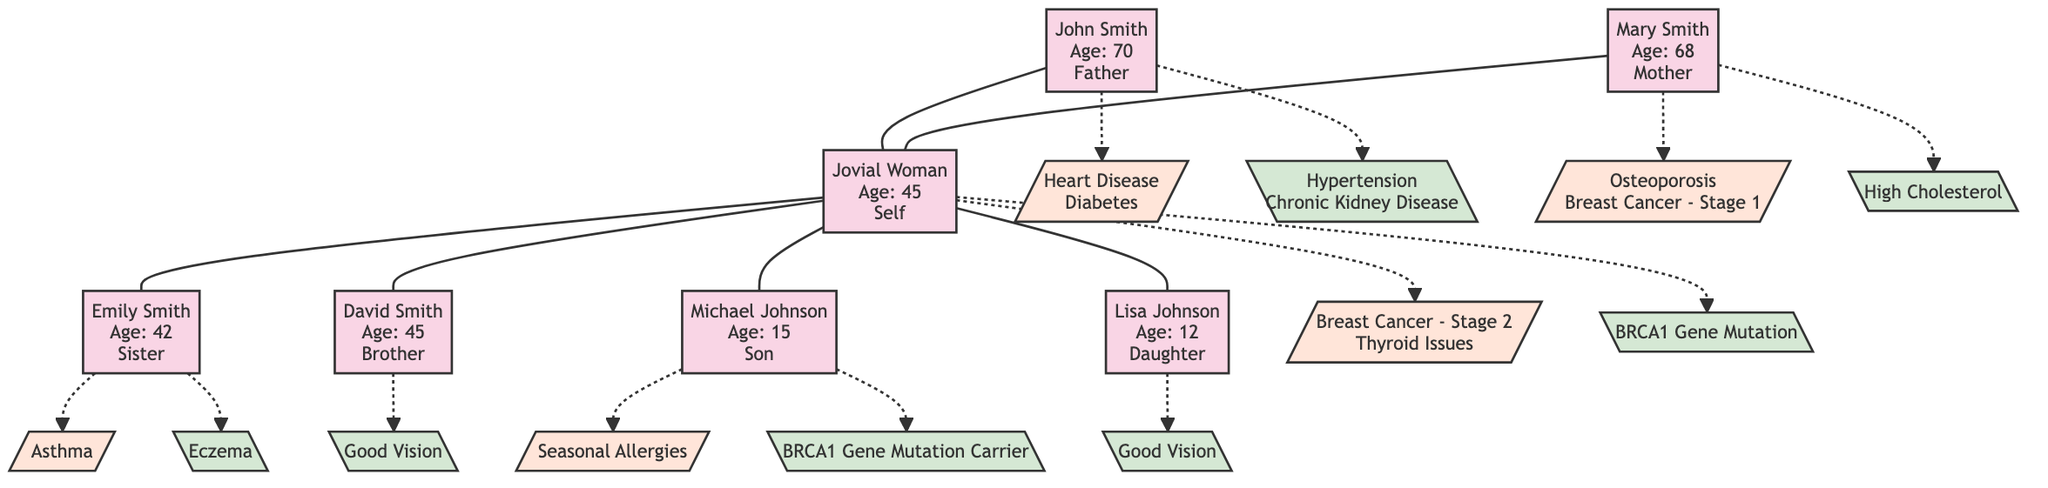What is the age of Jovial Woman? Jovial Woman's age is clearly displayed in her section of the diagram. It states "Age: 45".
Answer: 45 How many medical conditions does John Smith have? John Smith has a section detailing his medical conditions, which lists "Heart Disease" and "Diabetes" - a total of two medical conditions are mentioned.
Answer: 2 Which genetic trait is associated with Jovial Woman? The diagram specifically states Jovial Woman's genetic trait under her name as "BRCA1 Gene Mutation", located in her section.
Answer: BRCA1 Gene Mutation Who is the youngest member in the family tree? By examining the ages provided in the diagram, Lisa Johnson is 12 years old, which is younger than the others, thus she is the youngest member.
Answer: Lisa Johnson What medical condition does Michael Johnson have? In the section for Michael Johnson, it explicitly states he has "Seasonal Allergies", directly answering the question about his medical condition.
Answer: Seasonal Allergies Which family member has the genetic trait of "Good Vision"? Both David Smith and Lisa Johnson are listed with the genetic trait "Good Vision" in their respective sections of the diagram, indicating they share this trait.
Answer: David Smith, Lisa Johnson How many members are represented in the family tree? The total count of members is determined by simply counting the individual sections in the diagram; there are seven members listed in total.
Answer: 7 Which medical condition is shared between Jovial Woman and her mother? By reviewing the conditions listed for both Jovial Woman ("Breast Cancer - Stage 2") and her mother Mary Smith ("Breast Cancer - Stage 1"), we find that both have a form of breast cancer.
Answer: Breast Cancer Which relative has a condition that might lead to chronic illness? John Smith's medical conditions include "Heart Disease" and "Diabetes", both of which are chronic illnesses, indicating he has a serious health condition.
Answer: John Smith 